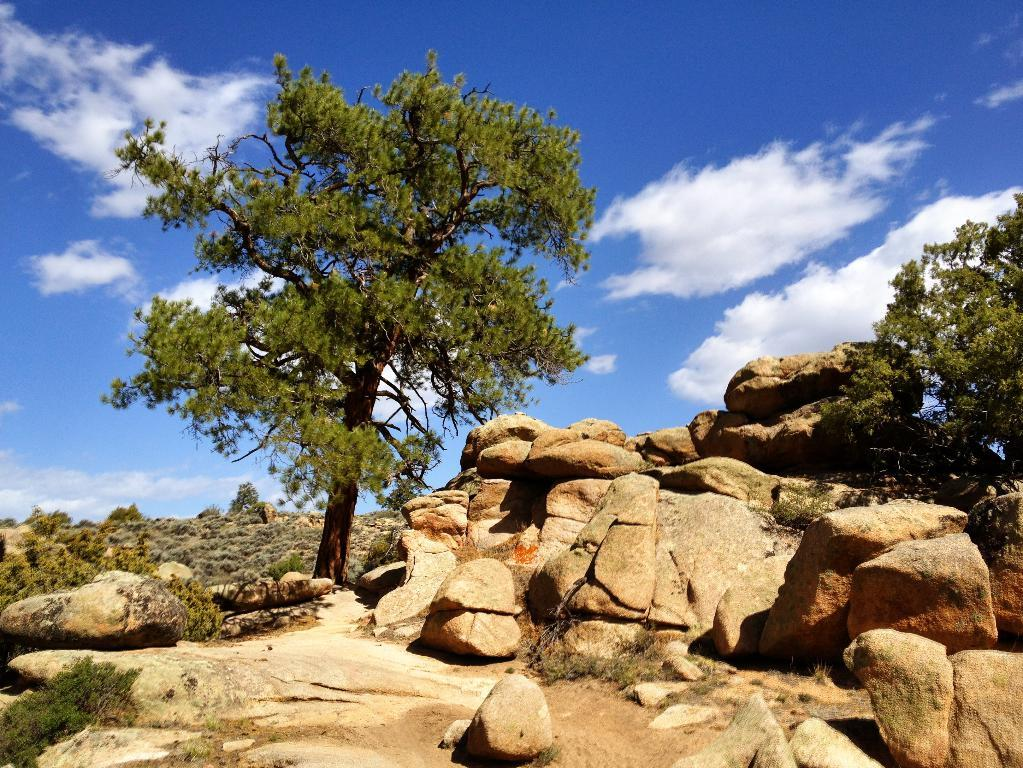What type of natural elements can be seen in the image? There are rocks, trees, and grass visible in the image. Where is the grass located in the image? The grass is on the left side of the image. What can be seen in the background of the image? There are clouds and the sky visible in the background of the image. What type of trade is happening between the rocks and trees in the image? There is no trade happening between the rocks and trees in the image, as they are inanimate objects. How much sugar is present in the grass on the left side of the image? There is no sugar present in the grass in the image, as it is a natural element and not a food item. 